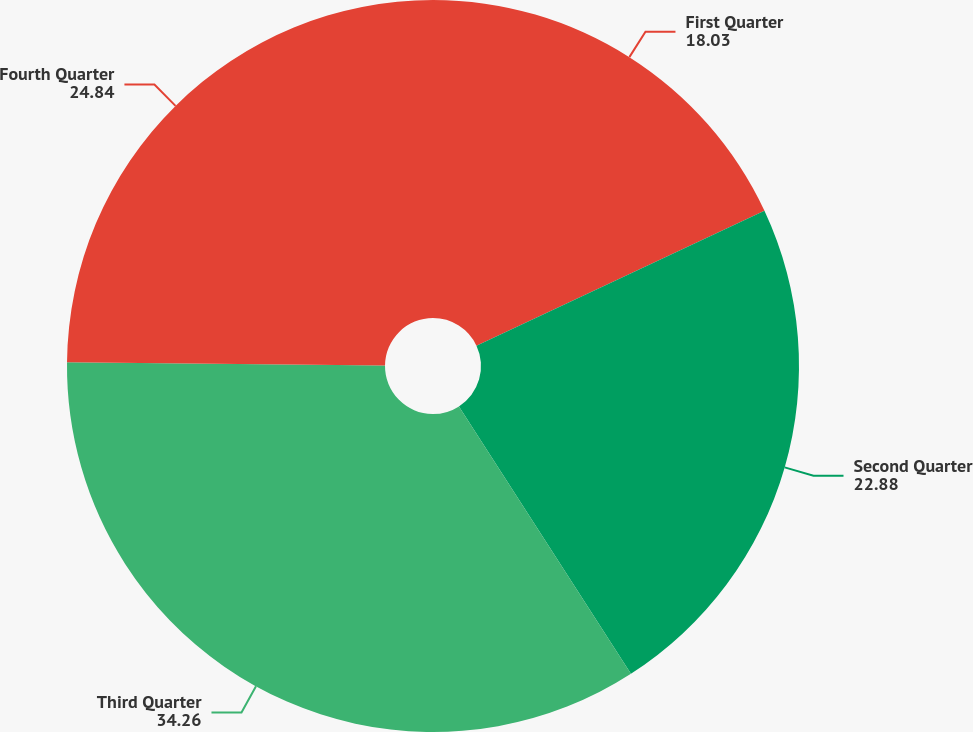<chart> <loc_0><loc_0><loc_500><loc_500><pie_chart><fcel>First Quarter<fcel>Second Quarter<fcel>Third Quarter<fcel>Fourth Quarter<nl><fcel>18.03%<fcel>22.88%<fcel>34.26%<fcel>24.84%<nl></chart> 